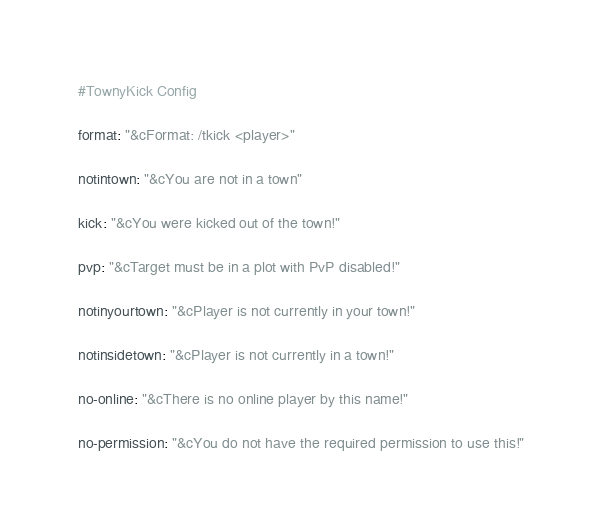<code> <loc_0><loc_0><loc_500><loc_500><_YAML_>#TownyKick Config

format: "&cFormat: /tkick <player>"

notintown: "&cYou are not in a town"

kick: "&cYou were kicked out of the town!"

pvp: "&cTarget must be in a plot with PvP disabled!"

notinyourtown: "&cPlayer is not currently in your town!"

notinsidetown: "&cPlayer is not currently in a town!"

no-online: "&cThere is no online player by this name!"

no-permission: "&cYou do not have the required permission to use this!"</code> 